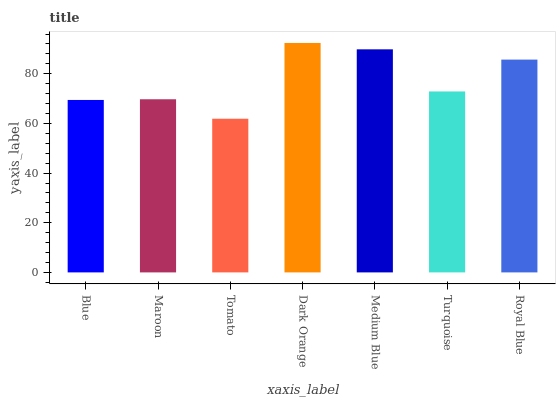Is Maroon the minimum?
Answer yes or no. No. Is Maroon the maximum?
Answer yes or no. No. Is Maroon greater than Blue?
Answer yes or no. Yes. Is Blue less than Maroon?
Answer yes or no. Yes. Is Blue greater than Maroon?
Answer yes or no. No. Is Maroon less than Blue?
Answer yes or no. No. Is Turquoise the high median?
Answer yes or no. Yes. Is Turquoise the low median?
Answer yes or no. Yes. Is Maroon the high median?
Answer yes or no. No. Is Dark Orange the low median?
Answer yes or no. No. 